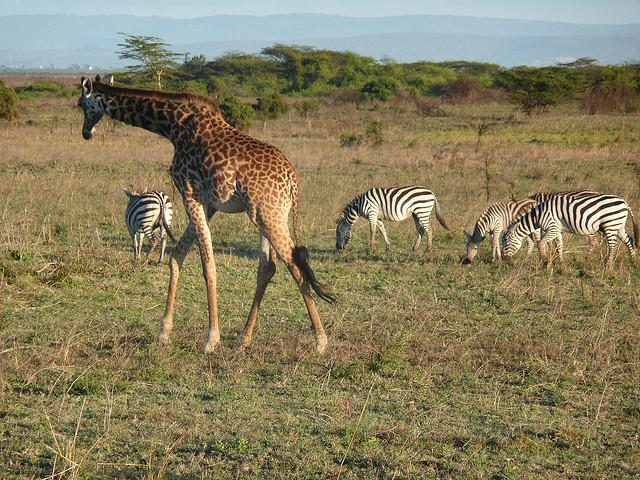What region is this most likely? Please explain your reasoning. east africa. East africa has wild animals. 